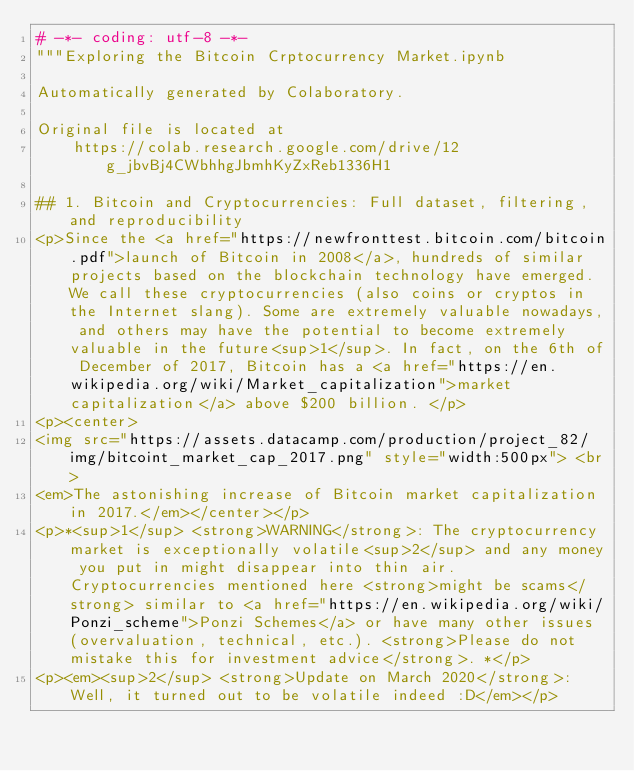<code> <loc_0><loc_0><loc_500><loc_500><_Python_># -*- coding: utf-8 -*-
"""Exploring the Bitcoin Crptocurrency Market.ipynb

Automatically generated by Colaboratory.

Original file is located at
    https://colab.research.google.com/drive/12g_jbvBj4CWbhhgJbmhKyZxReb1336H1

## 1. Bitcoin and Cryptocurrencies: Full dataset, filtering, and reproducibility
<p>Since the <a href="https://newfronttest.bitcoin.com/bitcoin.pdf">launch of Bitcoin in 2008</a>, hundreds of similar projects based on the blockchain technology have emerged. We call these cryptocurrencies (also coins or cryptos in the Internet slang). Some are extremely valuable nowadays, and others may have the potential to become extremely valuable in the future<sup>1</sup>. In fact, on the 6th of December of 2017, Bitcoin has a <a href="https://en.wikipedia.org/wiki/Market_capitalization">market capitalization</a> above $200 billion. </p>
<p><center>
<img src="https://assets.datacamp.com/production/project_82/img/bitcoint_market_cap_2017.png" style="width:500px"> <br> 
<em>The astonishing increase of Bitcoin market capitalization in 2017.</em></center></p>
<p>*<sup>1</sup> <strong>WARNING</strong>: The cryptocurrency market is exceptionally volatile<sup>2</sup> and any money you put in might disappear into thin air.  Cryptocurrencies mentioned here <strong>might be scams</strong> similar to <a href="https://en.wikipedia.org/wiki/Ponzi_scheme">Ponzi Schemes</a> or have many other issues (overvaluation, technical, etc.). <strong>Please do not mistake this for investment advice</strong>. *</p>
<p><em><sup>2</sup> <strong>Update on March 2020</strong>: Well, it turned out to be volatile indeed :D</em></p></code> 